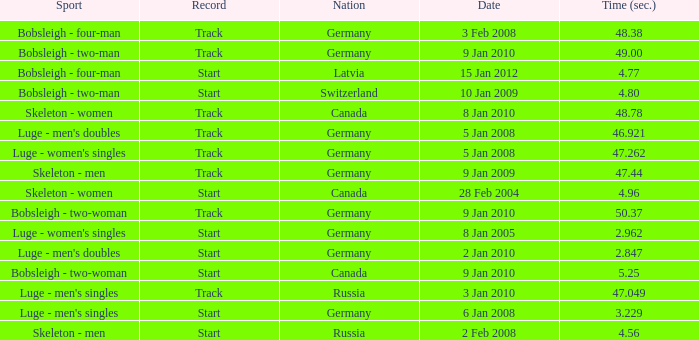Which nation had a time of 48.38? Germany. 